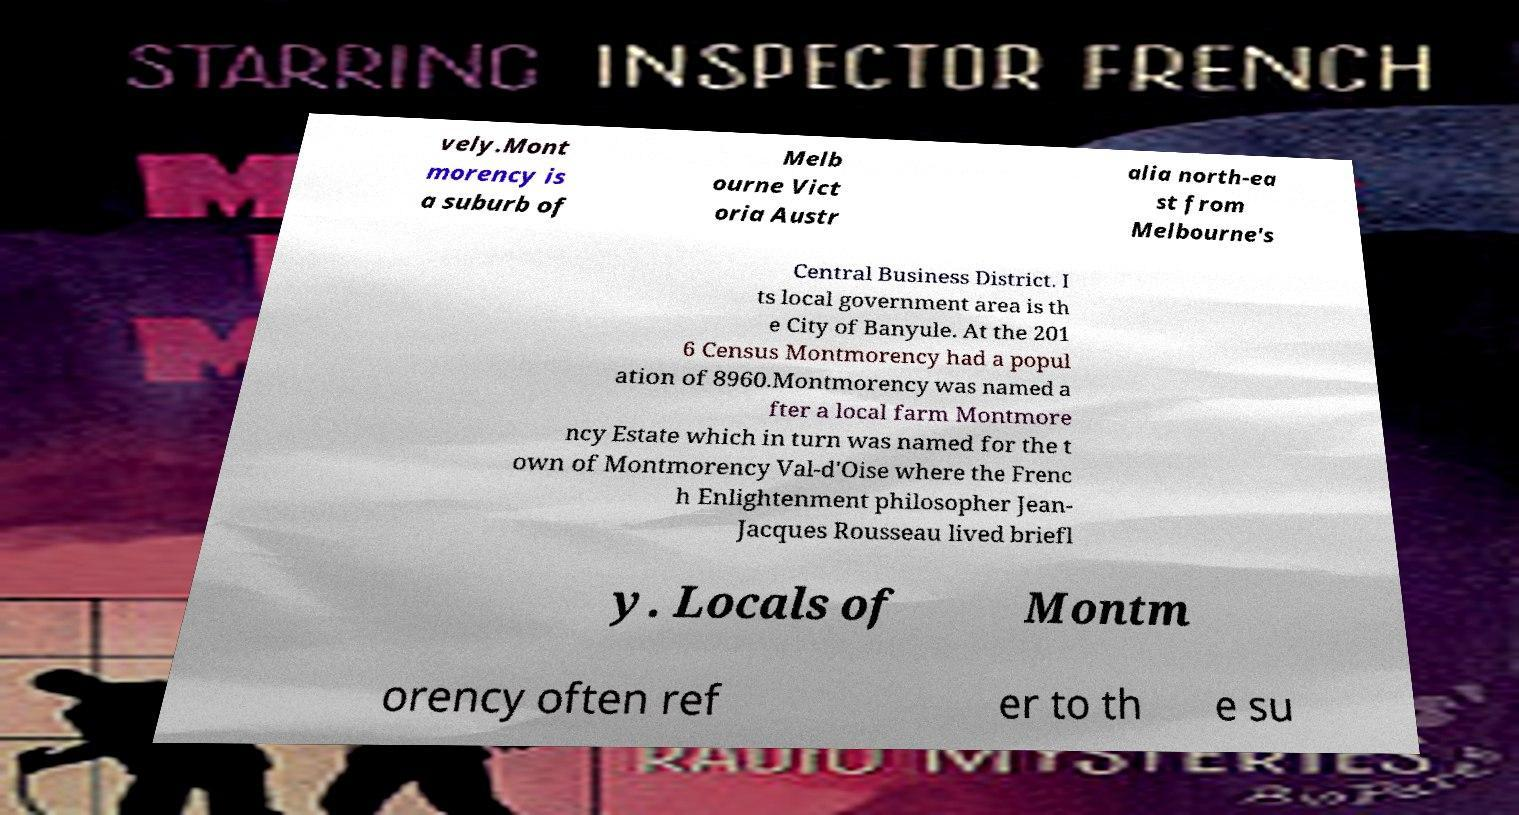Please read and relay the text visible in this image. What does it say? vely.Mont morency is a suburb of Melb ourne Vict oria Austr alia north-ea st from Melbourne's Central Business District. I ts local government area is th e City of Banyule. At the 201 6 Census Montmorency had a popul ation of 8960.Montmorency was named a fter a local farm Montmore ncy Estate which in turn was named for the t own of Montmorency Val-d'Oise where the Frenc h Enlightenment philosopher Jean- Jacques Rousseau lived briefl y. Locals of Montm orency often ref er to th e su 